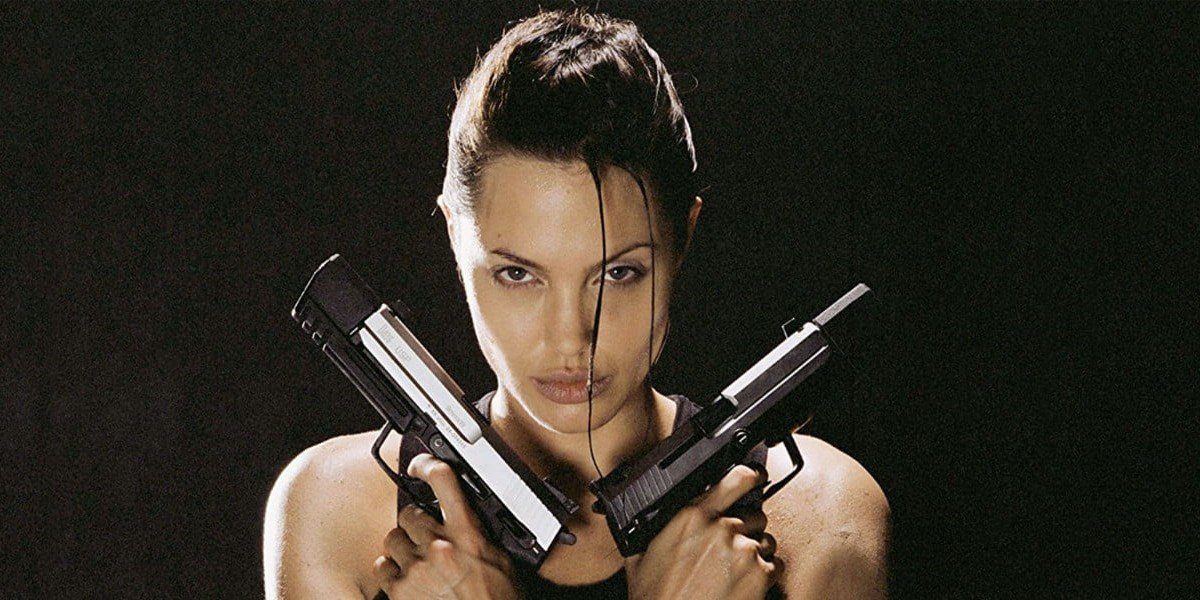Can you describe the mood and atmosphere of this image? The mood of this image is intense and dramatic. The character’s serious expression and the dark, minimalist background create a sense of impending action and danger. The crossed guns and her powerful stance contribute to an atmosphere of strength, determination, and readiness for battle. What can this image tell us about the character's personality? The image portrays the character as someone who is bold, confident, and resilient. Her firm grip on the guns and intense gaze suggest a no-nonsense attitude and a high level of preparedness, characteristics essential for someone who frequently faces danger and challenges. Her attire and posture indicate she is a warrior or adventurer, unafraid to confront whatever threats come her way. What scenarios do you think this character is versatile enough to handle? This character appears adept at handling a variety of high-stakes scenarios, from combat situations to navigating treacherous landscapes. She seems equipped to engage in strategic battles, conduct covert operations, or embark on treasure hunts across uncharted territories. Her preparation and warrior-like attributes hint that she could also manage situations requiring quick thinking and physical agility. 